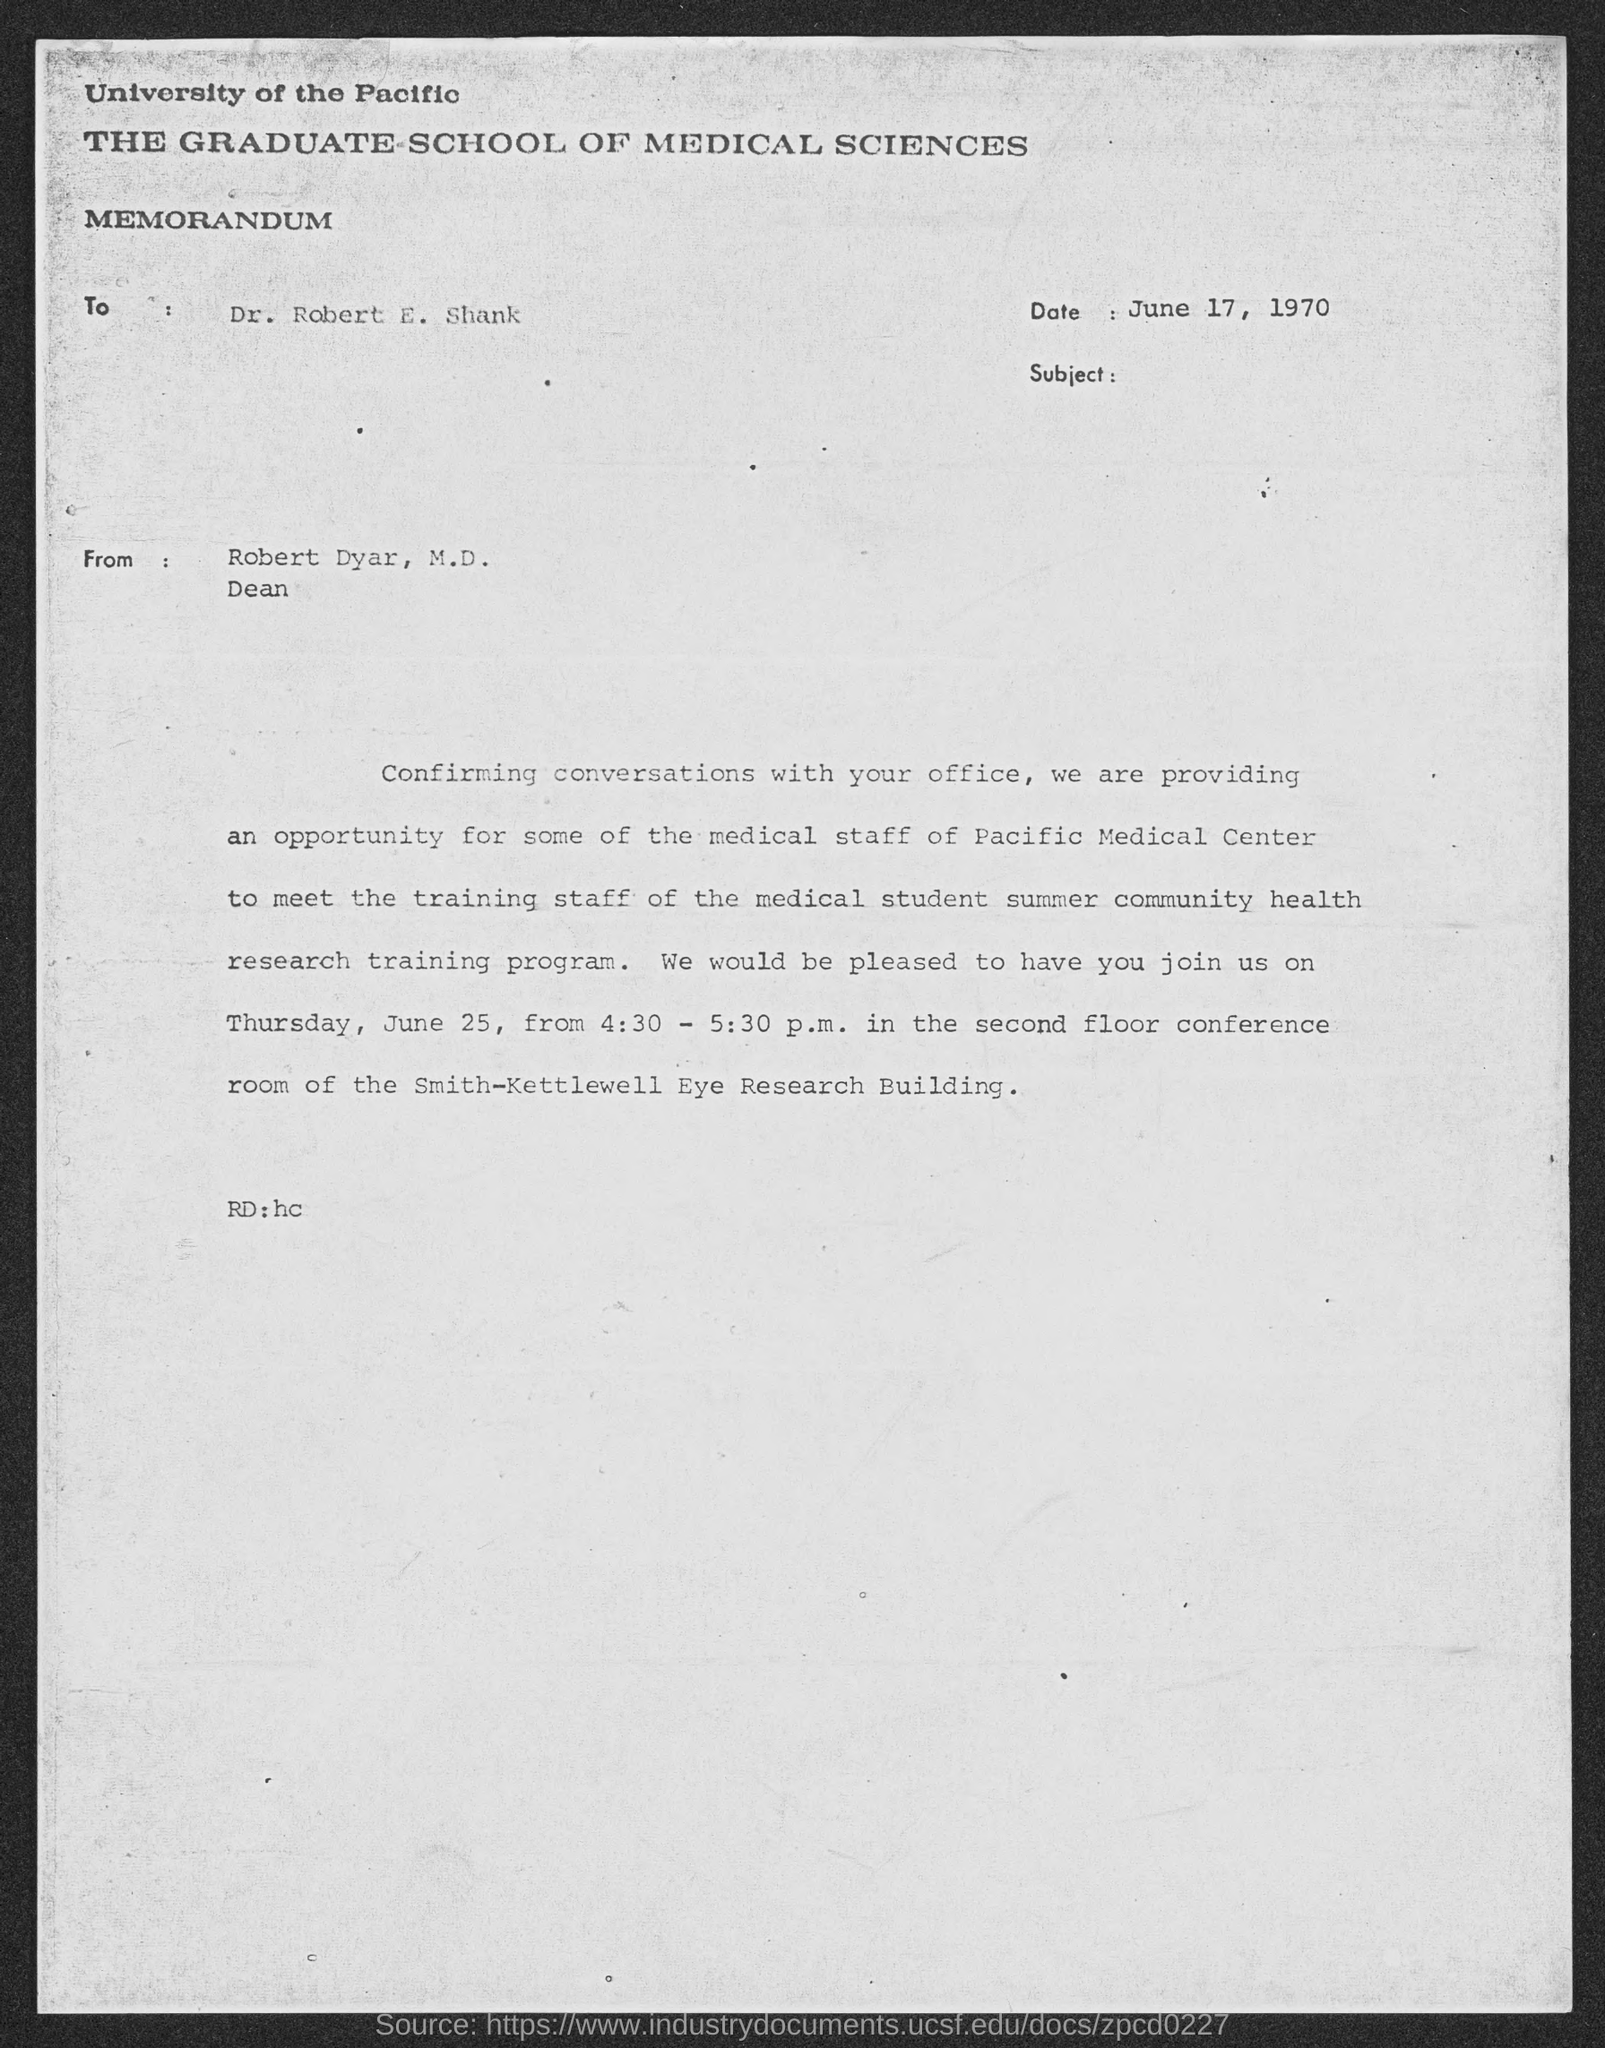When was the memorandum dated?
Offer a very short reply. June 17, 1970. Who wrote the letter?
Ensure brevity in your answer.  Robert Dyar, M.D. To whom the letter is addressed?
Your answer should be compact. Dr. Robert E. Shank. 